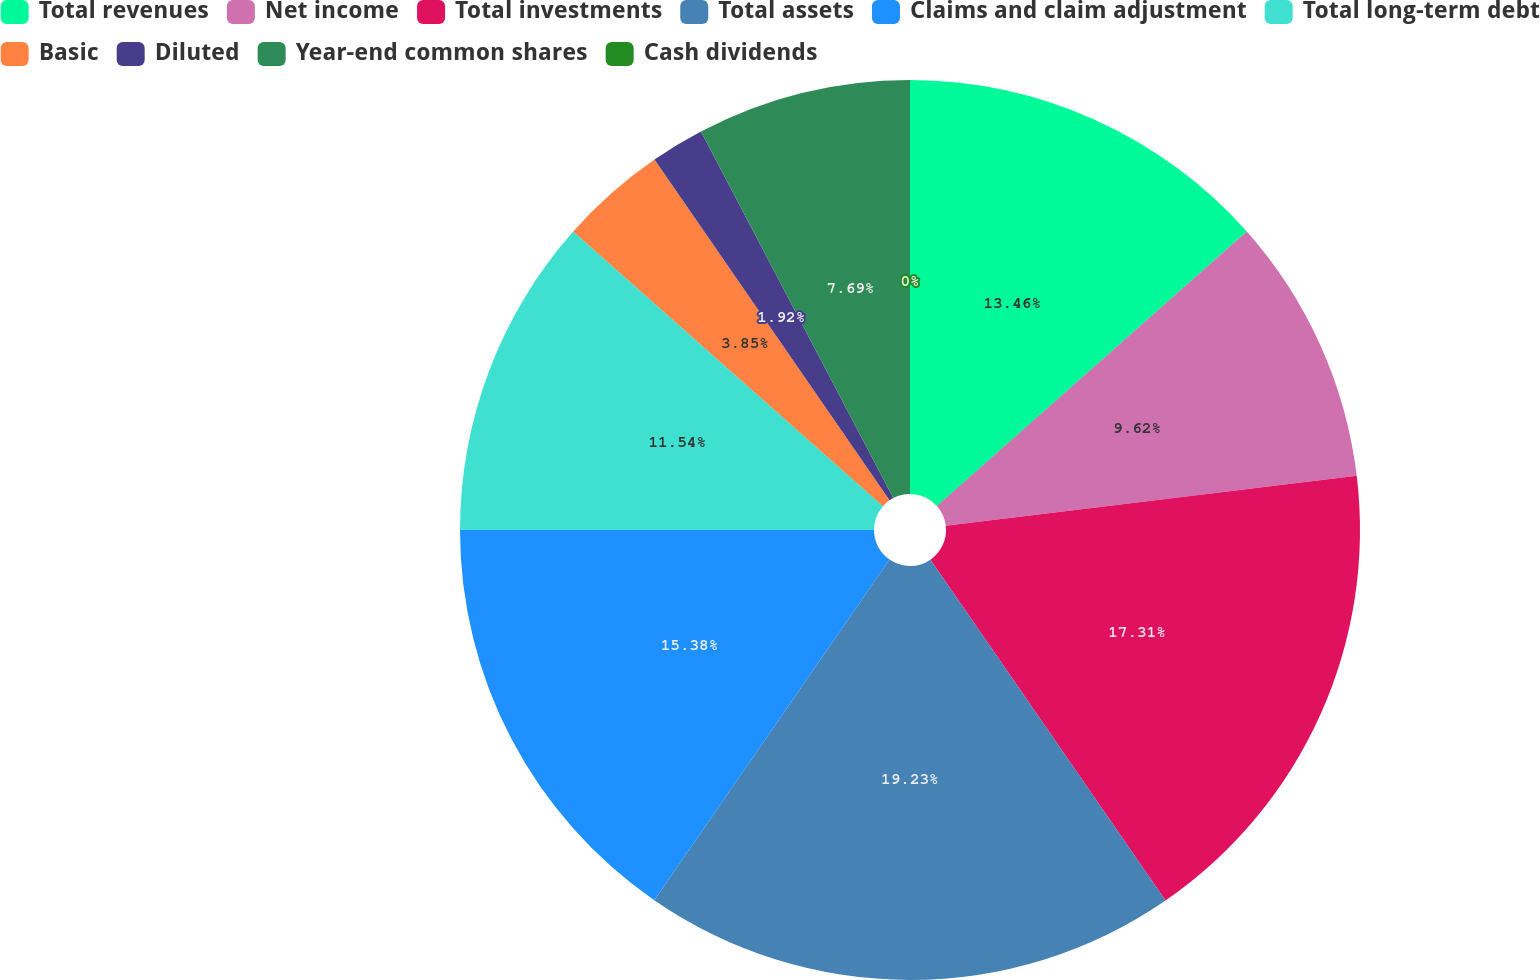<chart> <loc_0><loc_0><loc_500><loc_500><pie_chart><fcel>Total revenues<fcel>Net income<fcel>Total investments<fcel>Total assets<fcel>Claims and claim adjustment<fcel>Total long-term debt<fcel>Basic<fcel>Diluted<fcel>Year-end common shares<fcel>Cash dividends<nl><fcel>13.46%<fcel>9.62%<fcel>17.31%<fcel>19.23%<fcel>15.38%<fcel>11.54%<fcel>3.85%<fcel>1.92%<fcel>7.69%<fcel>0.0%<nl></chart> 